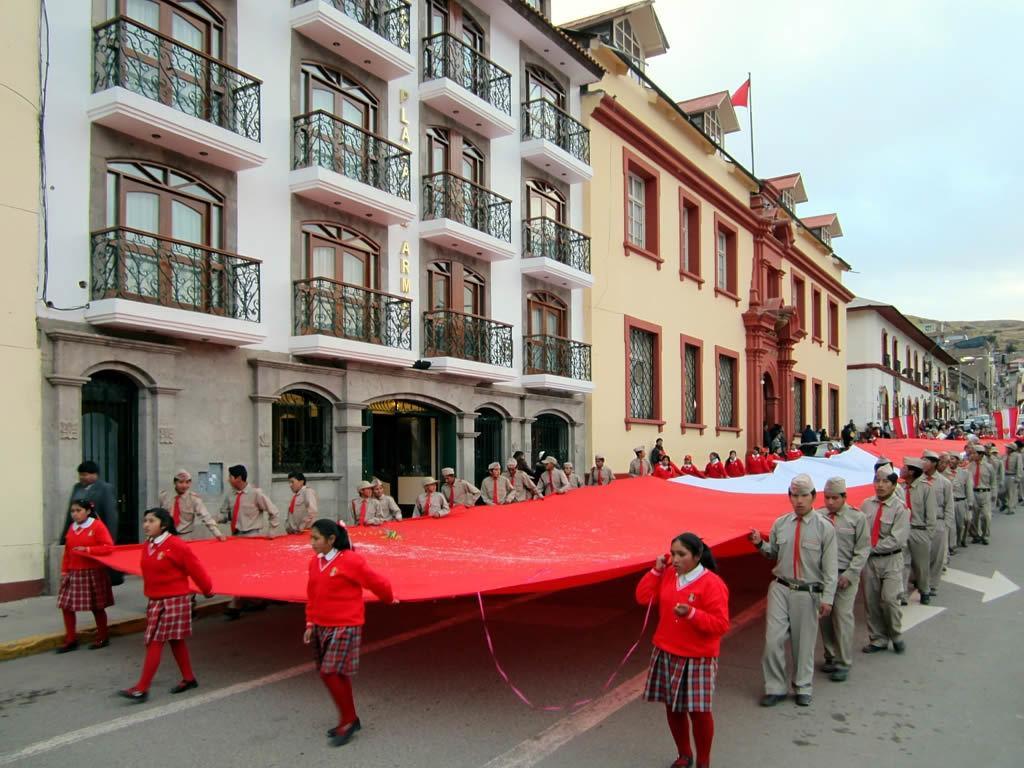How would you summarize this image in a sentence or two? In this picture we can see some people are walking on the road, they all are holding a cloth, side of the road we can see some buildings. 